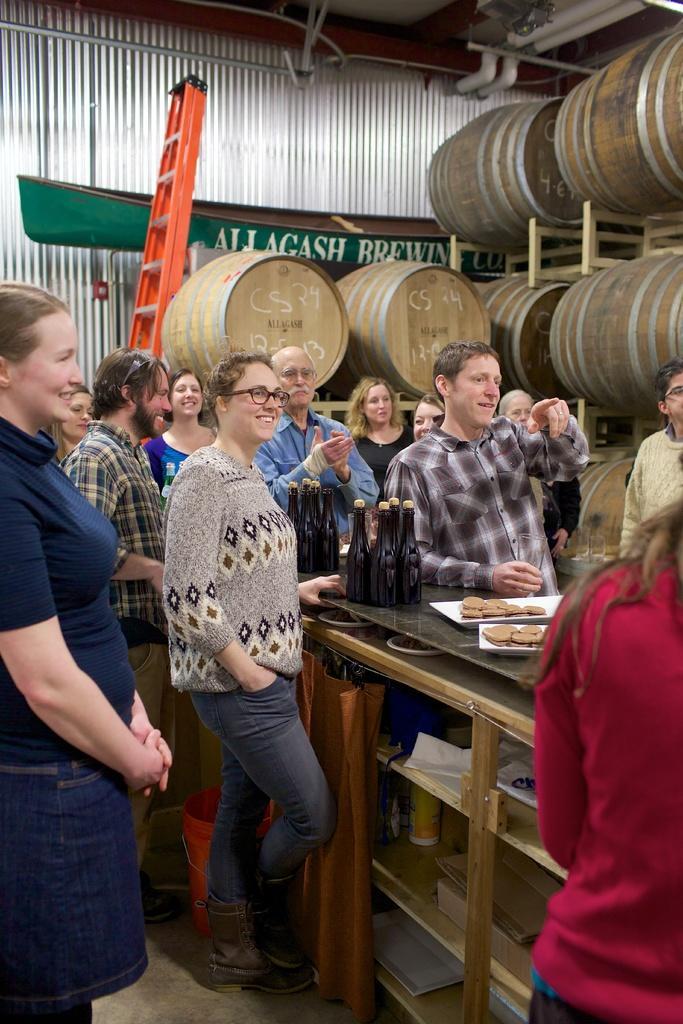Describe this image in one or two sentences. In a given image we can see many people standing and laughing some of them are clapping. This is a table on which bottles are kept and biscuits are kept in a plate. 